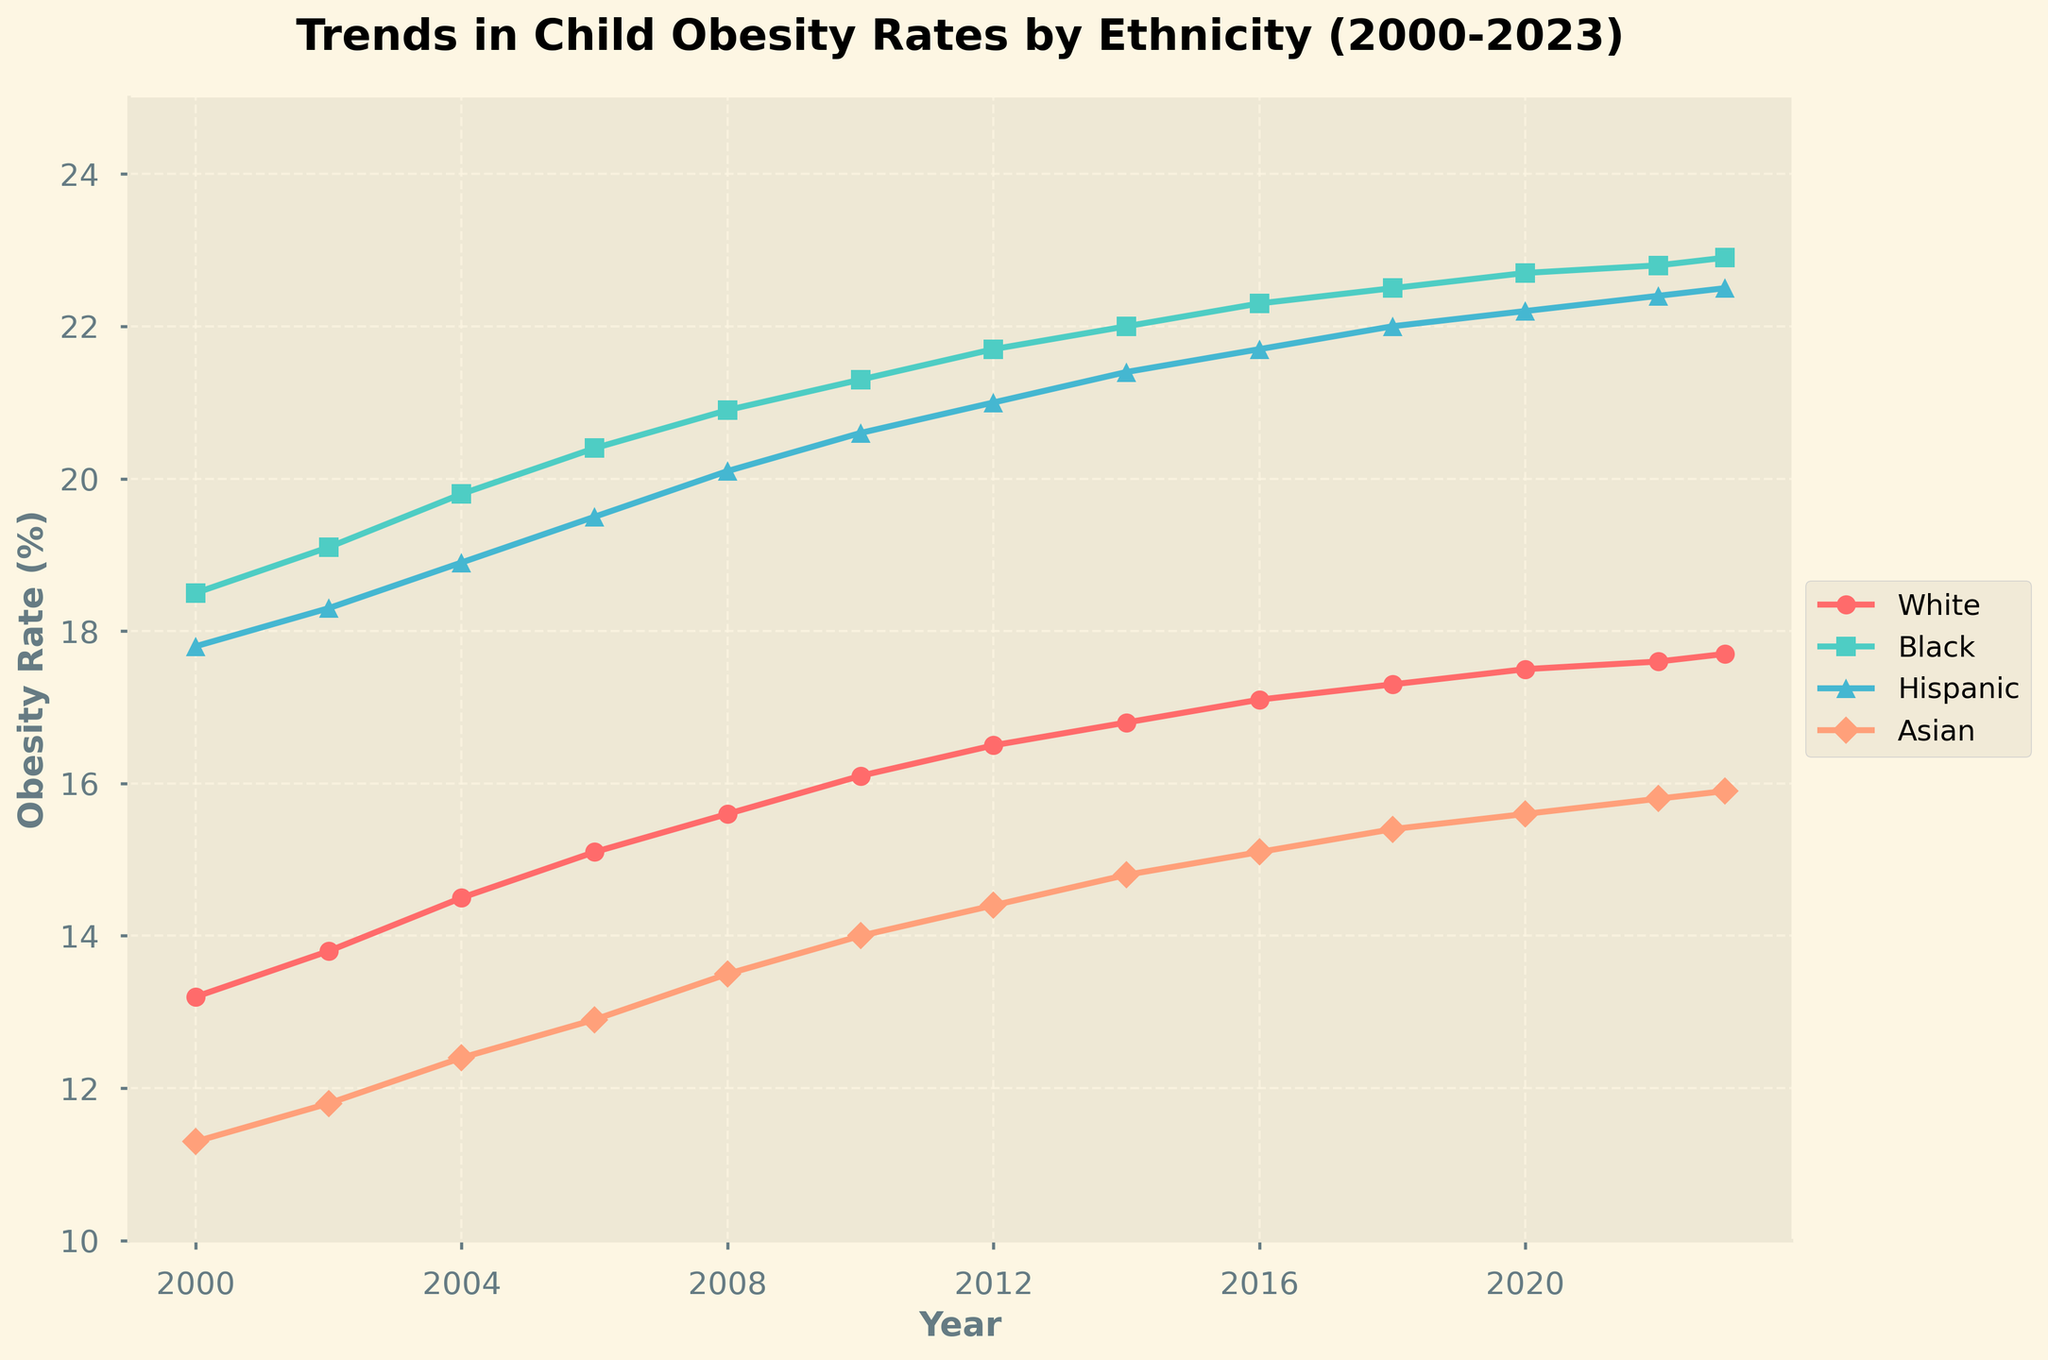which ethnic group had the lowest child obesity rate in 2000? By examining the plot, we see that in 2000 the Asian group had the lowest obesity rate at 11.3%.
Answer: Asian how did the obesity rates for the White and Hispanic groups compare in 2023? In 2023, the plot shows that the obesity rate for the White group was 17.7%, while for the Hispanic group, it was 22.5%. The Hispanic rate was higher.
Answer: Hispanic group had a higher rate What is the average child obesity rate for the Black group from 2000 to 2010? Sum the obesity rates for the Black group from 2000 (18.5), 2002(19.1), 2004 (19.8), 2006 (20.4), 2008 (20.9), and 2010 (21.3), then divide by 6. Average = (18.5 + 19.1 + 19.8 + 20.4 + 20.9 + 21.3) / 6 = 20.0%
Answer: 20.0% which ethnic group showed the biggest increase in obesity rate from 2000 to 2023? Calculate the difference in obesity rates from 2000 to 2023 for each group and compare them: White (17.7 - 13.2 = 4.5), Black (22.9 - 18.5 = 4.4), Hispanic (22.5 - 17.8 = 4.7), Asian (15.9 - 11.3 = 4.6). The Hispanic group had the biggest increase.
Answer: Hispanic Among the four ethnic groups, which group consistently had the highest obesity rates throughout the years? By examining the plot, the Black group consistently had the highest obesity rates compared to other groups throughout the years 2000-2023.
Answer: Black what's the difference in obesity rates between the Hispanic and Asian groups in 2023? In 2023, the obesity rate for the Hispanic group was 22.5% and for the Asian group, it was 15.9%. The difference is 22.5 - 15.9 = 6.6%.
Answer: 6.6% during which period did the White group's obesity rate increase the most sharply? We need to compare the slopes of the line segments for the White group between consecutive years. The period from 2008 to 2010 shows the sharpest increase, from 15.6% to 16.1%.
Answer: 2008 to 2010 what is the overall trend in child obesity rates for the Hispanic group from 2000 to 2023? The plot indicates that the obesity rates for the Hispanic group have risen steadily from 17.8% in 2000 to 22.5% in 2023, showing an upward trend.
Answer: upward trend 